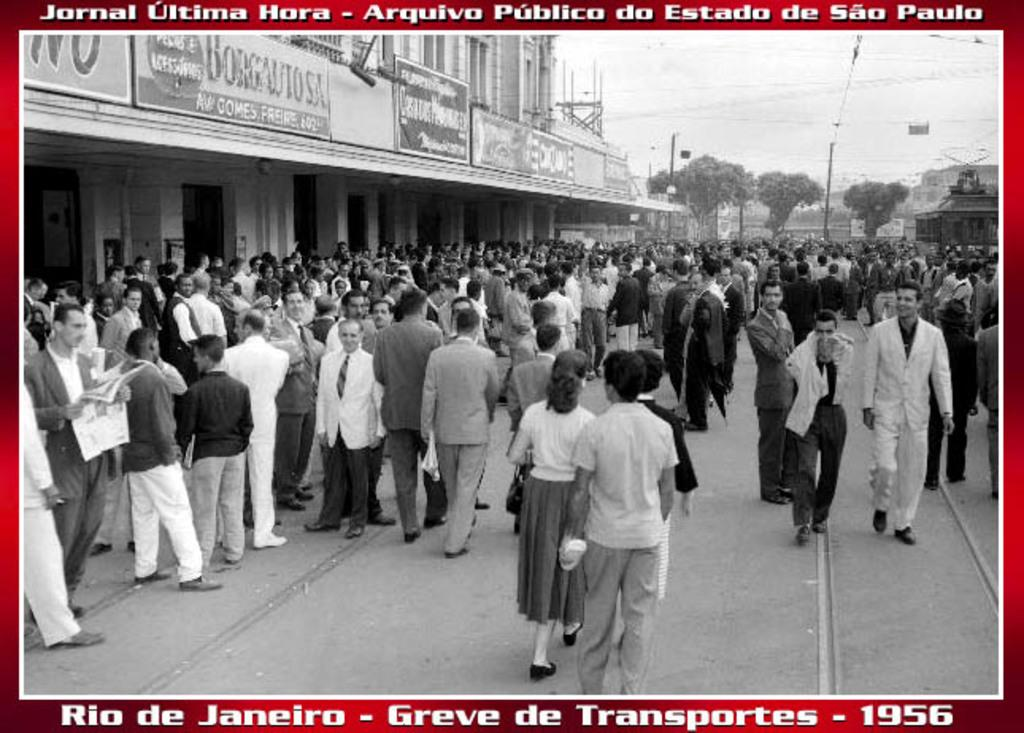<image>
Present a compact description of the photo's key features. A picture of Rio De Janeiro taken in 1956 shows a busy street full of people 